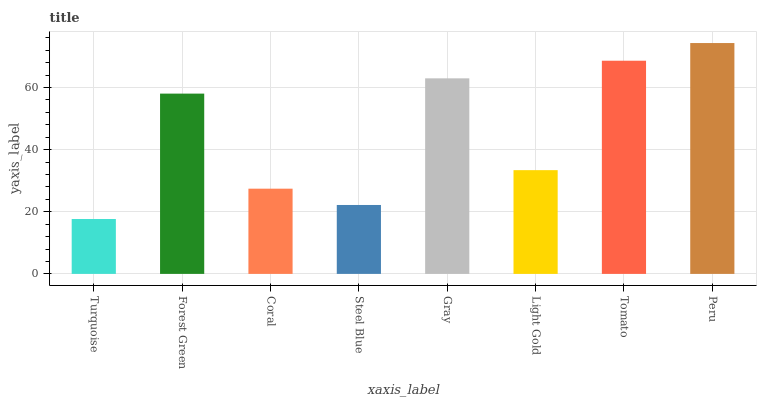Is Turquoise the minimum?
Answer yes or no. Yes. Is Peru the maximum?
Answer yes or no. Yes. Is Forest Green the minimum?
Answer yes or no. No. Is Forest Green the maximum?
Answer yes or no. No. Is Forest Green greater than Turquoise?
Answer yes or no. Yes. Is Turquoise less than Forest Green?
Answer yes or no. Yes. Is Turquoise greater than Forest Green?
Answer yes or no. No. Is Forest Green less than Turquoise?
Answer yes or no. No. Is Forest Green the high median?
Answer yes or no. Yes. Is Light Gold the low median?
Answer yes or no. Yes. Is Light Gold the high median?
Answer yes or no. No. Is Coral the low median?
Answer yes or no. No. 